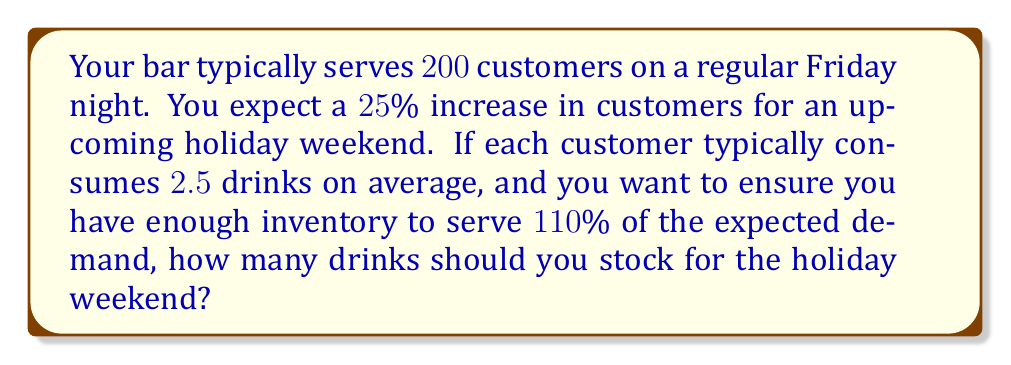Give your solution to this math problem. 1. Calculate the expected number of customers for the holiday weekend:
   Regular customers: $200$
   Increase: $25\% = 0.25$
   Additional customers: $200 \times 0.25 = 50$
   Total expected customers: $200 + 50 = 250$

2. Calculate the expected number of drinks needed:
   Drinks per customer: $2.5$
   Expected drinks: $250 \times 2.5 = 625$

3. Add a $10\%$ buffer to ensure enough inventory:
   Buffer factor: $110\% = 1.1$
   Total drinks to stock: $625 \times 1.1 = 687.5$

4. Round up to the nearest whole number:
   Drinks to stock: $688$
Answer: $688$ drinks 